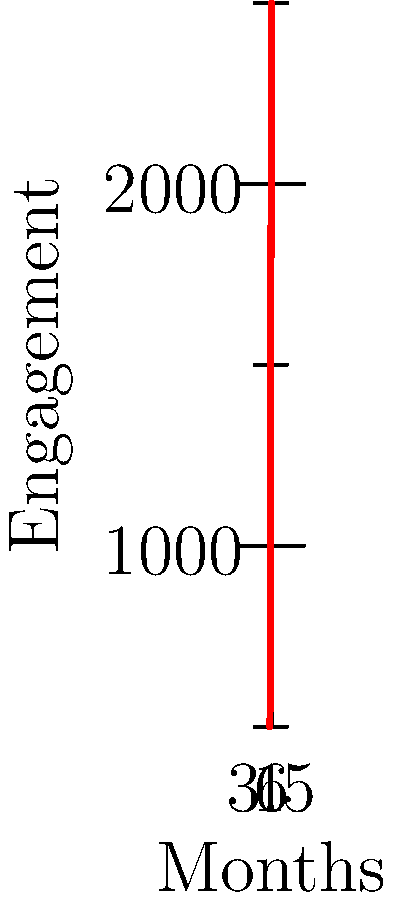As the guitarist in a local rock band, you're analyzing your band's social media engagement over the past six months. The line graph shows the trend in engagement from January to June. What was the percentage increase in engagement from January to June? To calculate the percentage increase in engagement from January to June, we'll follow these steps:

1. Identify the engagement values:
   January (initial): 500
   June (final): 2500

2. Calculate the difference:
   $2500 - 500 = 2000$

3. Divide the difference by the initial value:
   $2000 \div 500 = 4$

4. Convert to percentage:
   $4 \times 100\% = 400\%$

Therefore, the percentage increase in engagement from January to June was 400%.
Answer: 400% 